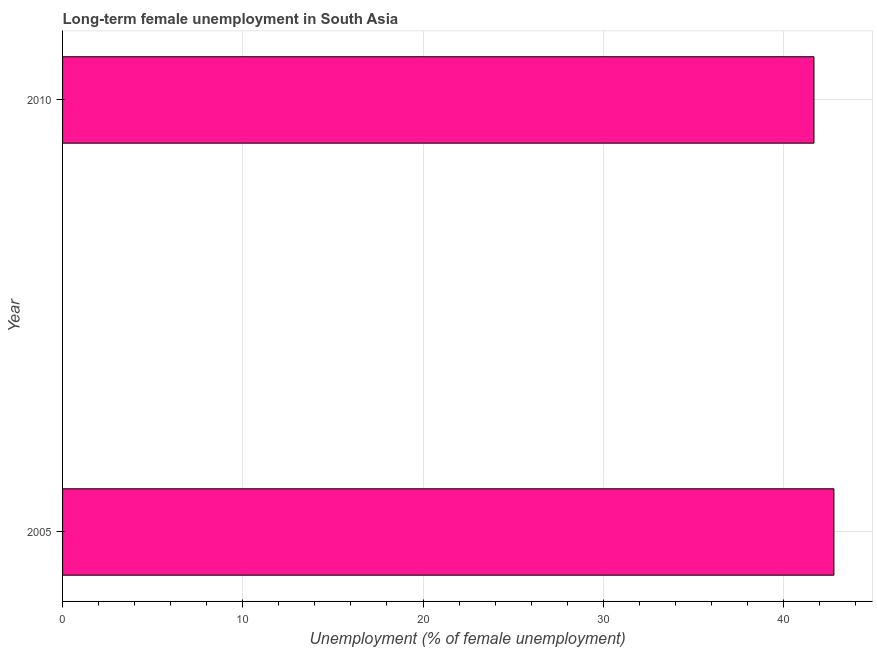Does the graph contain grids?
Offer a terse response. Yes. What is the title of the graph?
Your answer should be compact. Long-term female unemployment in South Asia. What is the label or title of the X-axis?
Your answer should be very brief. Unemployment (% of female unemployment). What is the label or title of the Y-axis?
Your answer should be compact. Year. What is the long-term female unemployment in 2005?
Offer a terse response. 42.8. Across all years, what is the maximum long-term female unemployment?
Make the answer very short. 42.8. Across all years, what is the minimum long-term female unemployment?
Offer a very short reply. 41.69. In which year was the long-term female unemployment minimum?
Offer a very short reply. 2010. What is the sum of the long-term female unemployment?
Ensure brevity in your answer.  84.49. What is the difference between the long-term female unemployment in 2005 and 2010?
Your answer should be very brief. 1.11. What is the average long-term female unemployment per year?
Provide a succinct answer. 42.25. What is the median long-term female unemployment?
Provide a succinct answer. 42.25. In how many years, is the long-term female unemployment greater than 12 %?
Provide a succinct answer. 2. Do a majority of the years between 2010 and 2005 (inclusive) have long-term female unemployment greater than 28 %?
Ensure brevity in your answer.  No. What is the ratio of the long-term female unemployment in 2005 to that in 2010?
Ensure brevity in your answer.  1.03. Is the long-term female unemployment in 2005 less than that in 2010?
Provide a succinct answer. No. In how many years, is the long-term female unemployment greater than the average long-term female unemployment taken over all years?
Provide a short and direct response. 1. How many bars are there?
Ensure brevity in your answer.  2. How many years are there in the graph?
Give a very brief answer. 2. Are the values on the major ticks of X-axis written in scientific E-notation?
Your answer should be very brief. No. What is the Unemployment (% of female unemployment) in 2005?
Your response must be concise. 42.8. What is the Unemployment (% of female unemployment) of 2010?
Offer a very short reply. 41.69. What is the difference between the Unemployment (% of female unemployment) in 2005 and 2010?
Give a very brief answer. 1.11. 